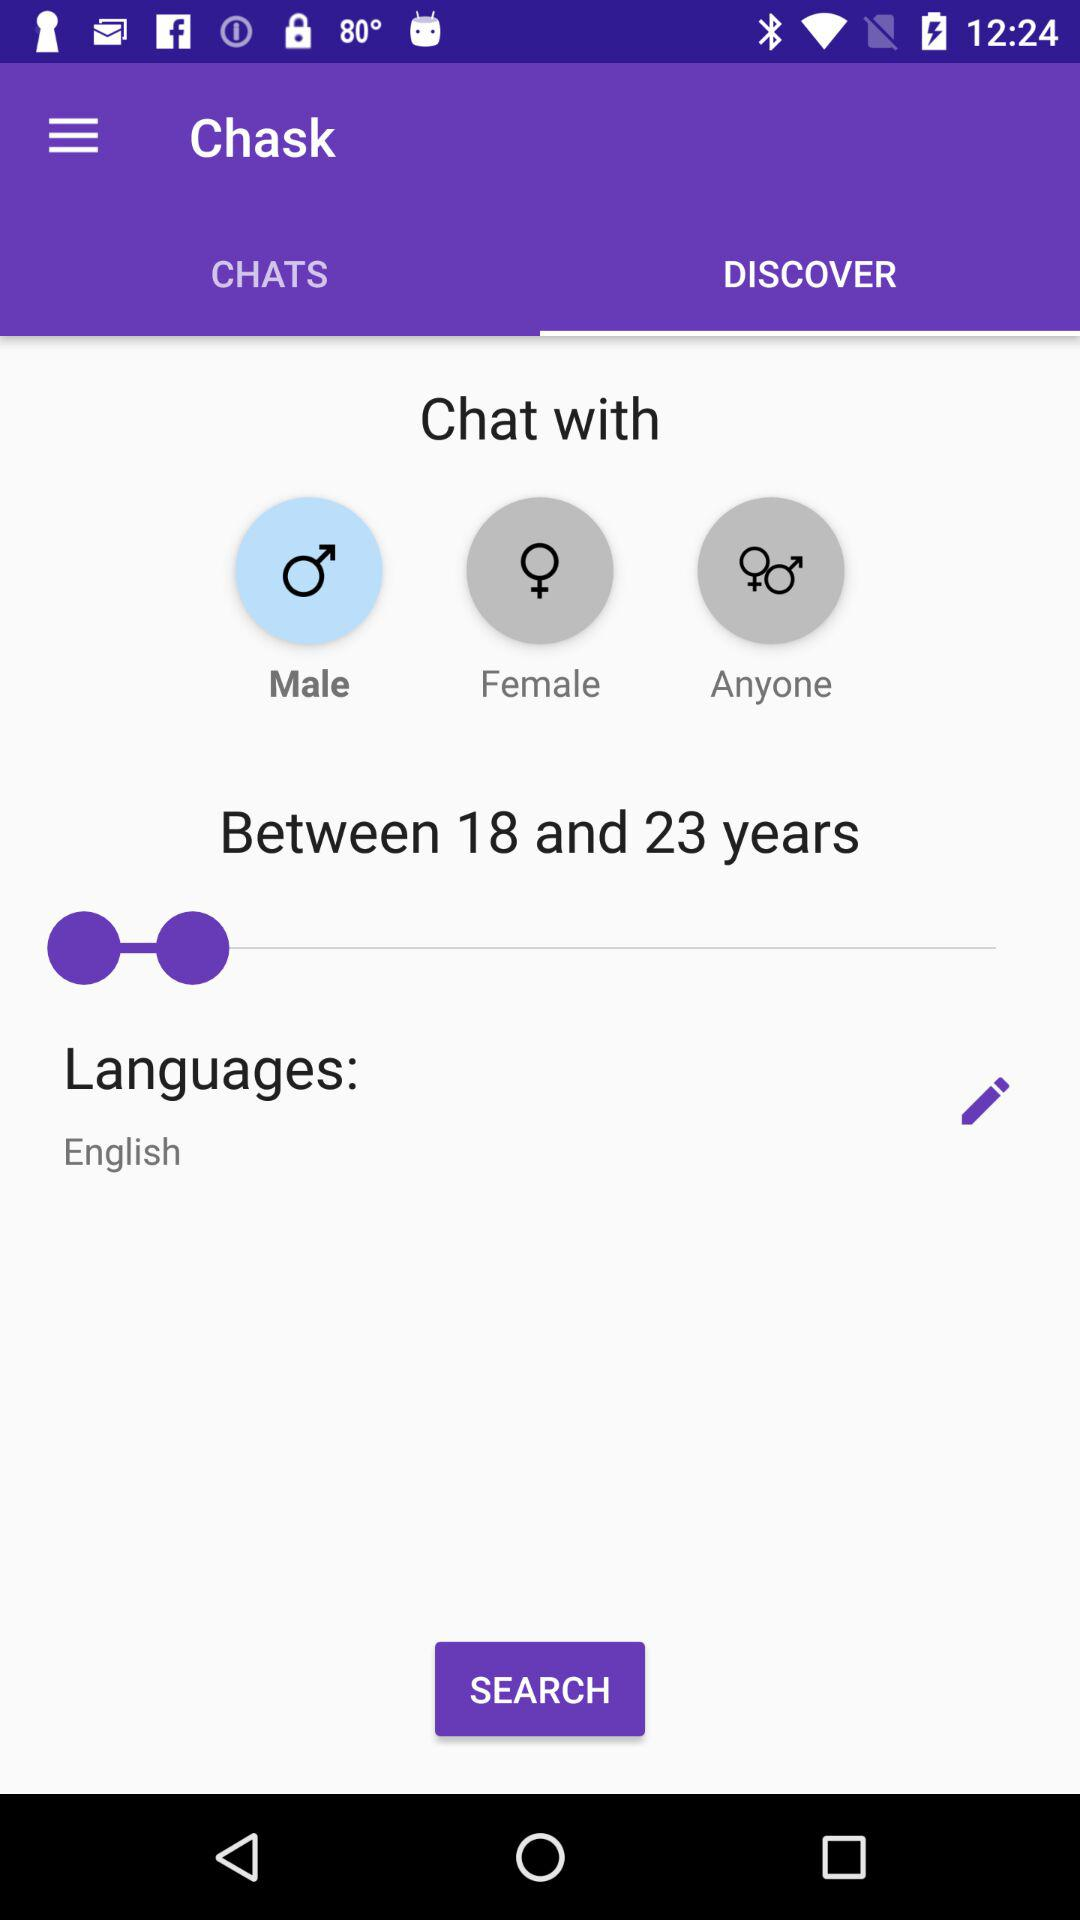What option is selected to chat with? The selected option is "Male". 